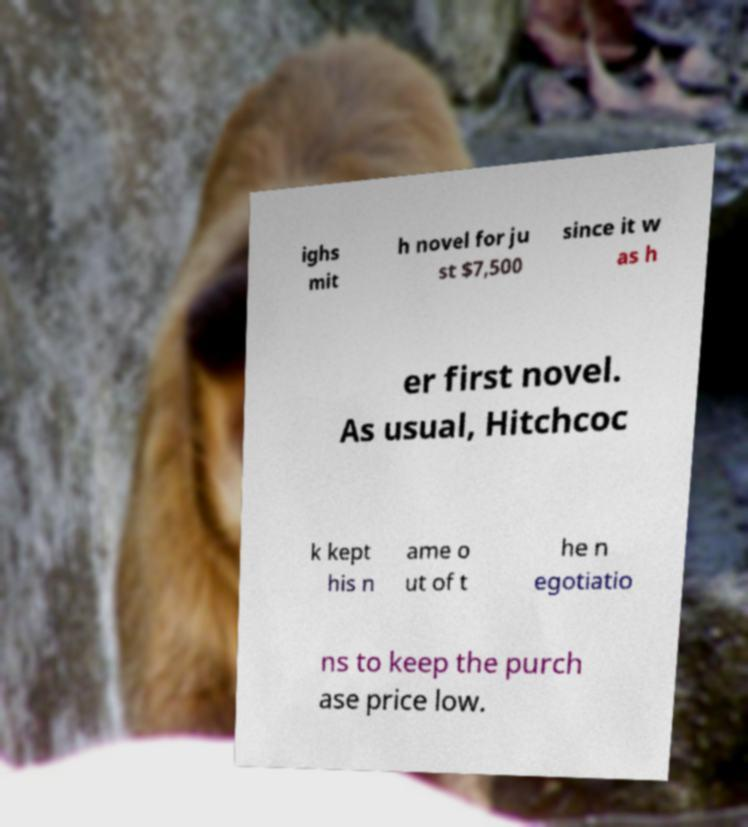Could you assist in decoding the text presented in this image and type it out clearly? ighs mit h novel for ju st $7,500 since it w as h er first novel. As usual, Hitchcoc k kept his n ame o ut of t he n egotiatio ns to keep the purch ase price low. 